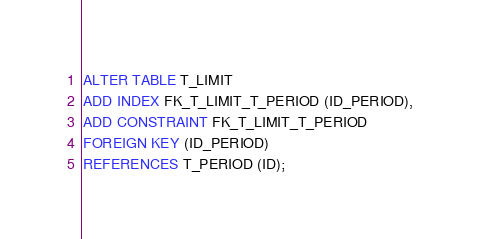Convert code to text. <code><loc_0><loc_0><loc_500><loc_500><_SQL_>
ALTER TABLE T_LIMIT
ADD INDEX FK_T_LIMIT_T_PERIOD (ID_PERIOD),
ADD CONSTRAINT FK_T_LIMIT_T_PERIOD
FOREIGN KEY (ID_PERIOD)
REFERENCES T_PERIOD (ID);</code> 